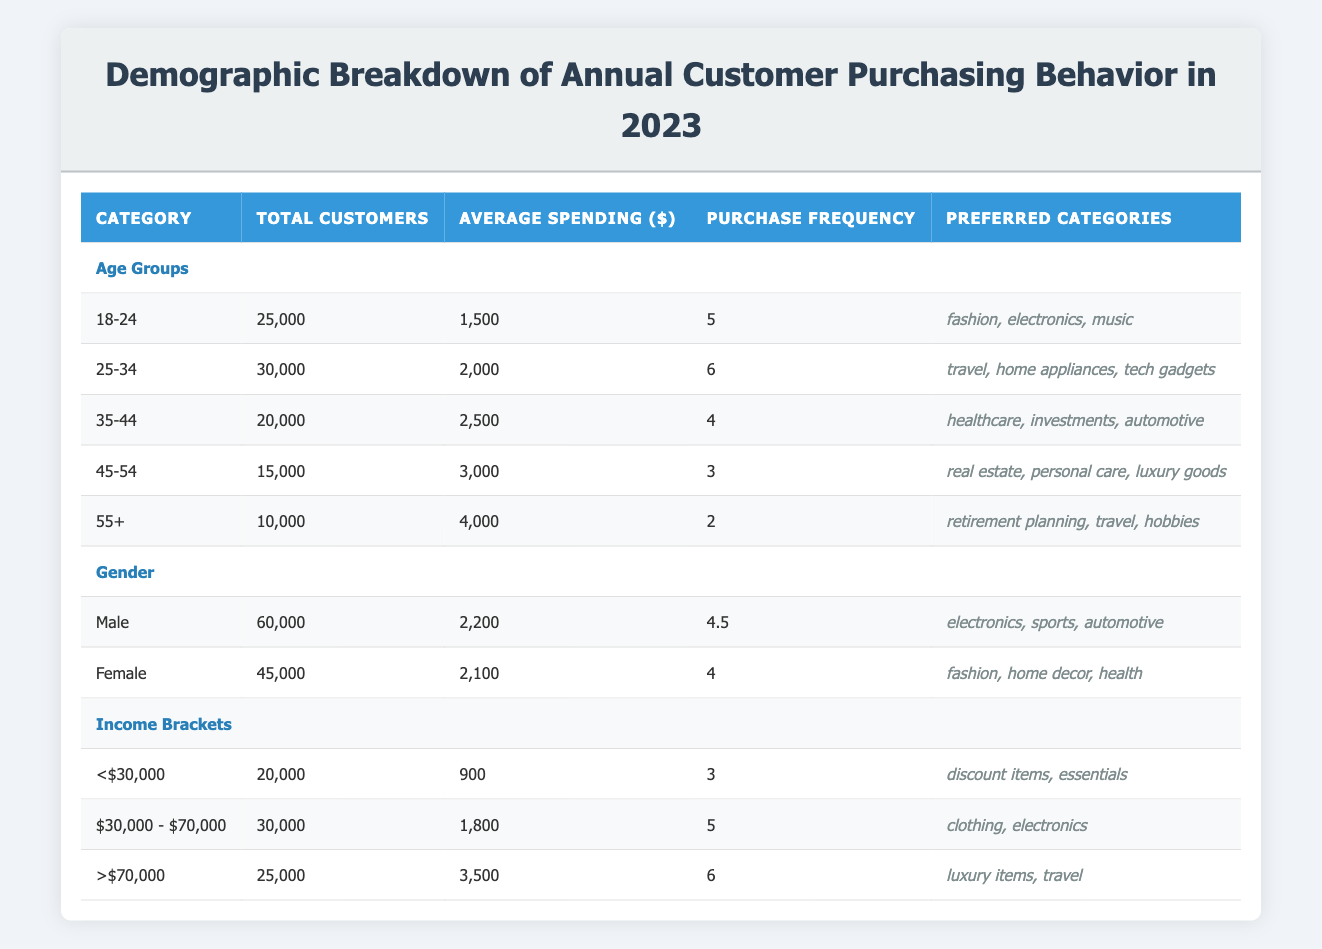What is the total number of customers in the age range 25-34? The total number of customers in the age range 25-34 is explicitly listed in the table under the age groups section. Referring to that row, we see the total customers for the age range 25-34 is 30,000.
Answer: 30,000 Which age group has the highest average spending? To find the age group with the highest average spending, we compare the average spending values from each age group listed in the table. The 55+ age group has an average spending of 4,000, which is greater than all other age groups.
Answer: 55+ What is the average purchase frequency of female customers? The average purchase frequency for female customers is listed under the gender section of the table. The table shows that for females, the purchase frequency is 4.
Answer: 4 Is the average spending of customers in the income range >$70,000 higher than that of customers in the income range <$30,000? To answer this, we compare the average spending values from the two income brackets. For >$70,000, it is 3,500, and for <$30,000, it is 900. Since 3,500 is greater than 900, the statement is true.
Answer: Yes What is the total number of male customers who purchase electronics? The table shows that male customers have an average spending preference for electronics, but it does not specify the exact number of male customers purchasing electronics directly. However, the total number of male customers listed is 60,000, but we cannot determine how many specifically purchase electronics without additional data.
Answer: Not enough information 